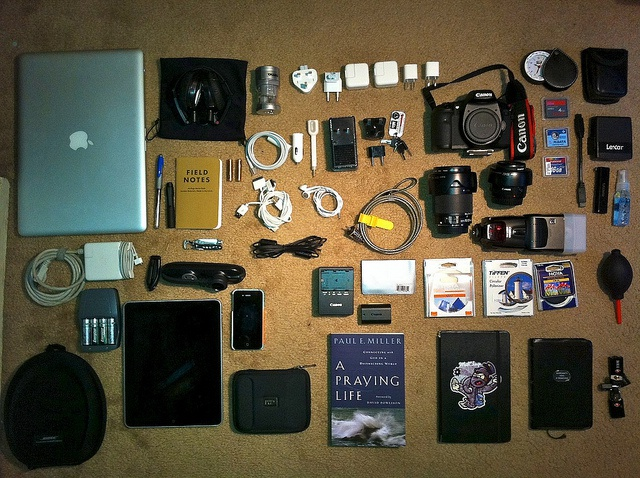Describe the objects in this image and their specific colors. I can see laptop in black and teal tones, book in black, navy, gray, and darkgray tones, book in black, gray, darkgray, and lightgray tones, book in black and olive tones, and cell phone in black, ivory, gray, and darkgray tones in this image. 